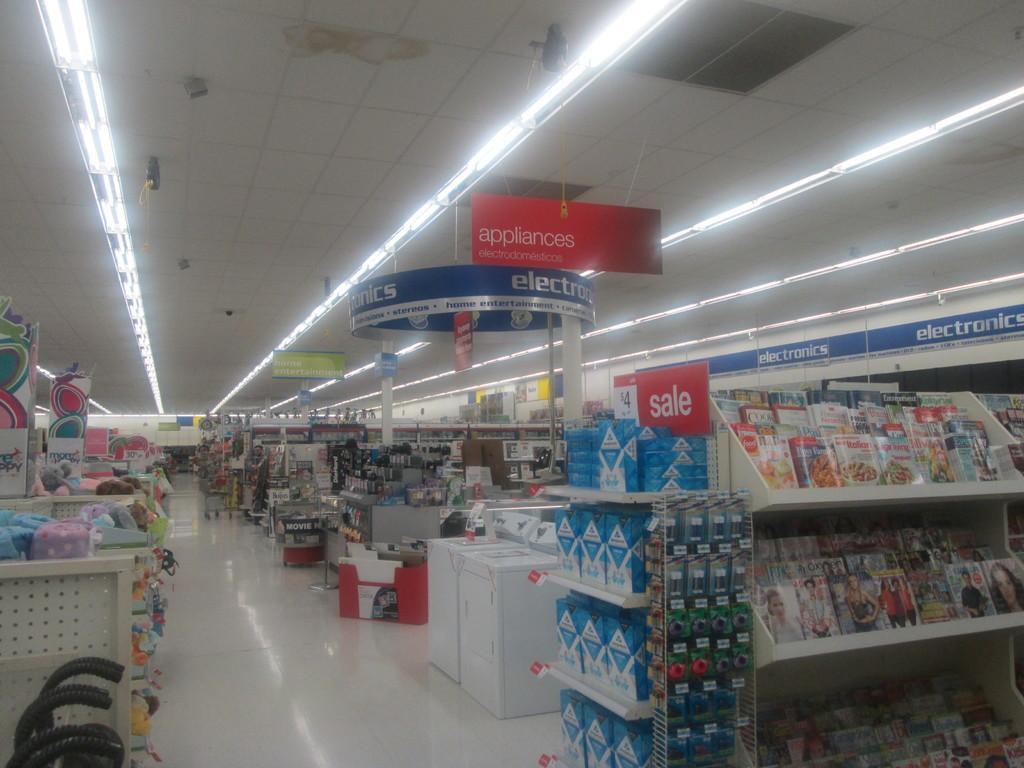<image>
Create a compact narrative representing the image presented. An electronics department of a store with a red Sale sign 